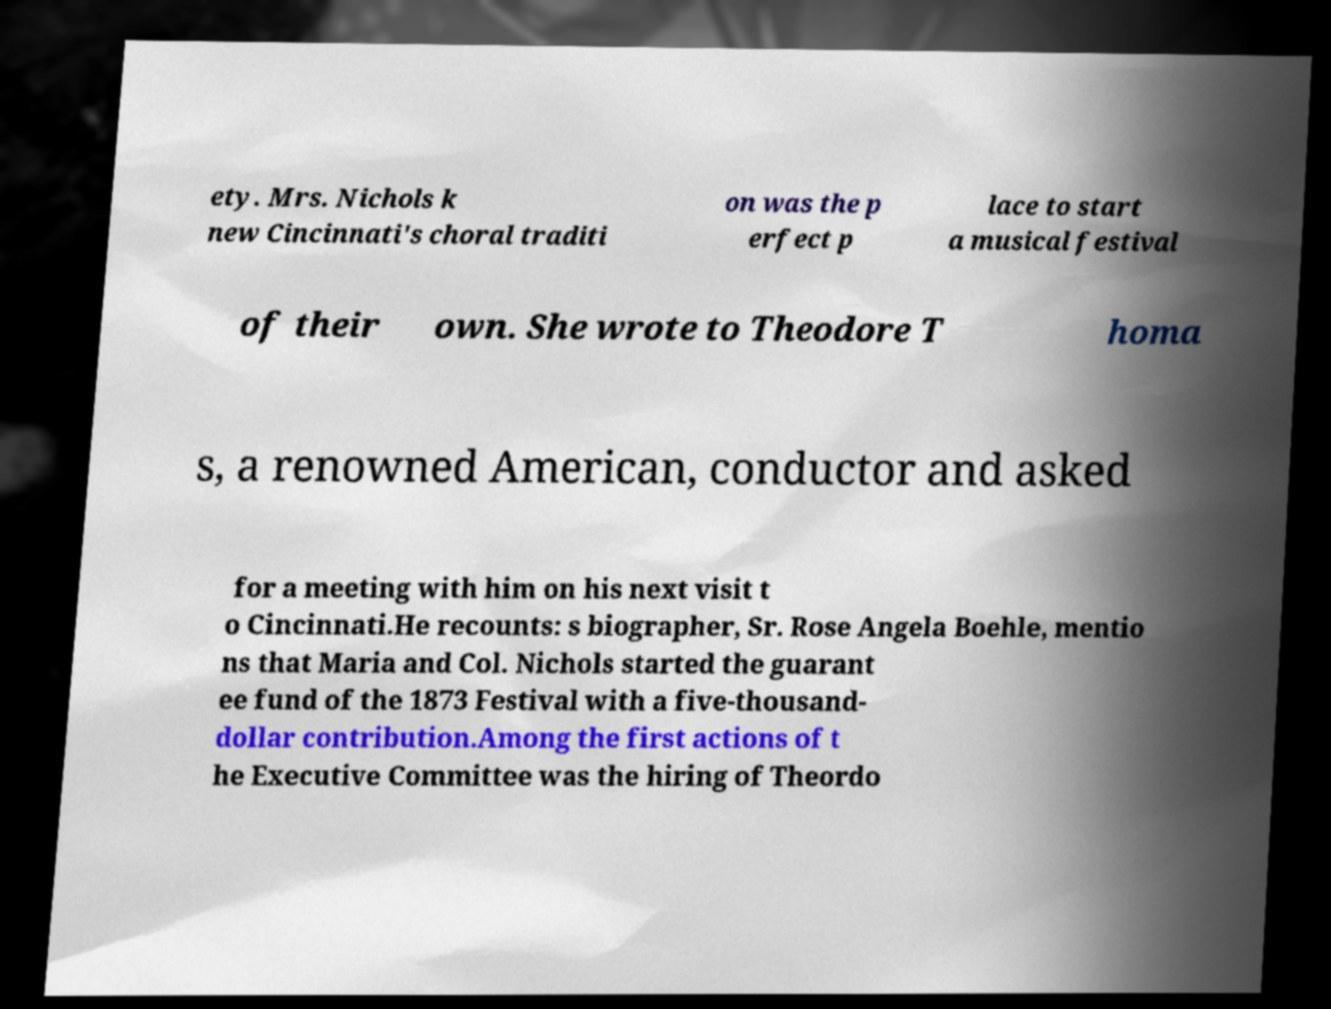Could you assist in decoding the text presented in this image and type it out clearly? ety. Mrs. Nichols k new Cincinnati's choral traditi on was the p erfect p lace to start a musical festival of their own. She wrote to Theodore T homa s, a renowned American, conductor and asked for a meeting with him on his next visit t o Cincinnati.He recounts: s biographer, Sr. Rose Angela Boehle, mentio ns that Maria and Col. Nichols started the guarant ee fund of the 1873 Festival with a five-thousand- dollar contribution.Among the first actions of t he Executive Committee was the hiring of Theordo 